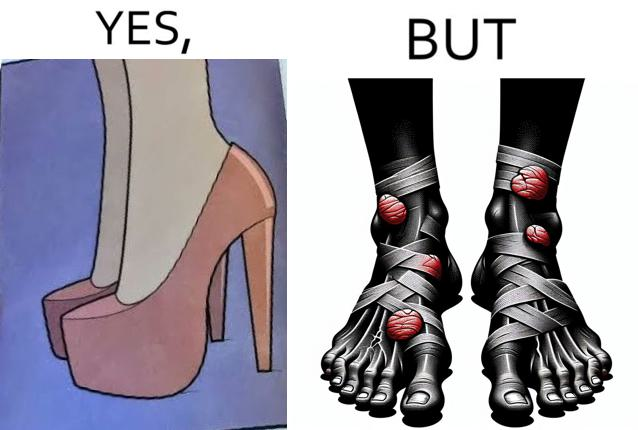Explain why this image is satirical. The images are funny since they show how the prettiest footwears like high heels, end up causing a lot of physical discomfort to the user, all in the name fashion 